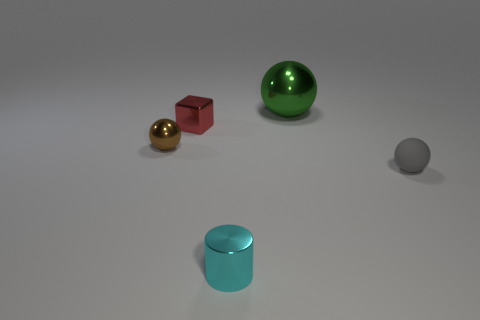Add 3 big matte objects. How many objects exist? 8 Subtract all spheres. How many objects are left? 2 Add 1 small blocks. How many small blocks are left? 2 Add 3 brown metal spheres. How many brown metal spheres exist? 4 Subtract 0 blue spheres. How many objects are left? 5 Subtract all tiny green shiny cylinders. Subtract all large metallic balls. How many objects are left? 4 